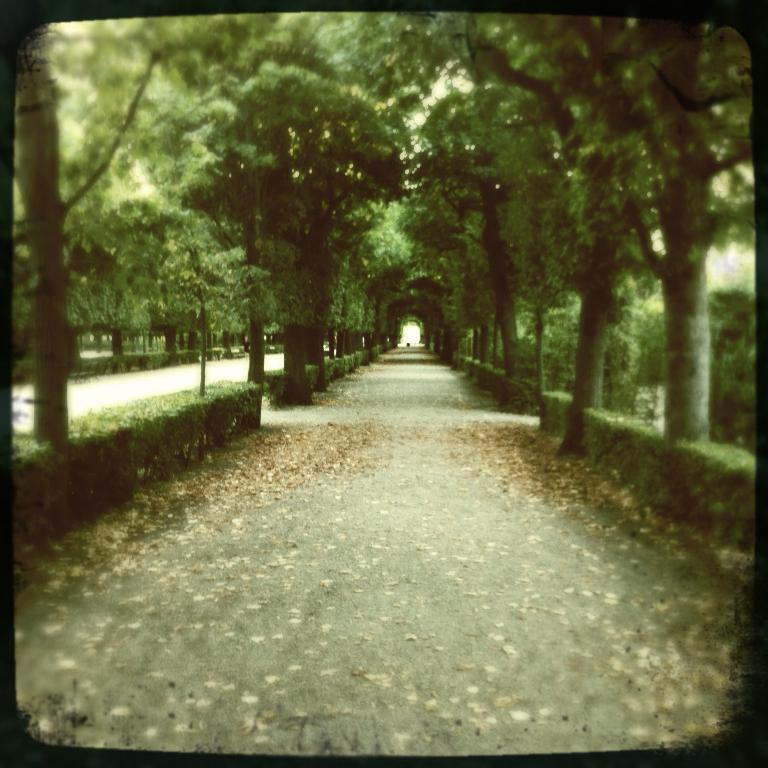What type of vegetation can be seen in the image? There are trees visible in the image. Where are the trees located in relation to the roads? The trees are located behind the roads. How many fish can be seen swimming in the trees in the image? There are no fish present in the image, as it features trees and roads. 